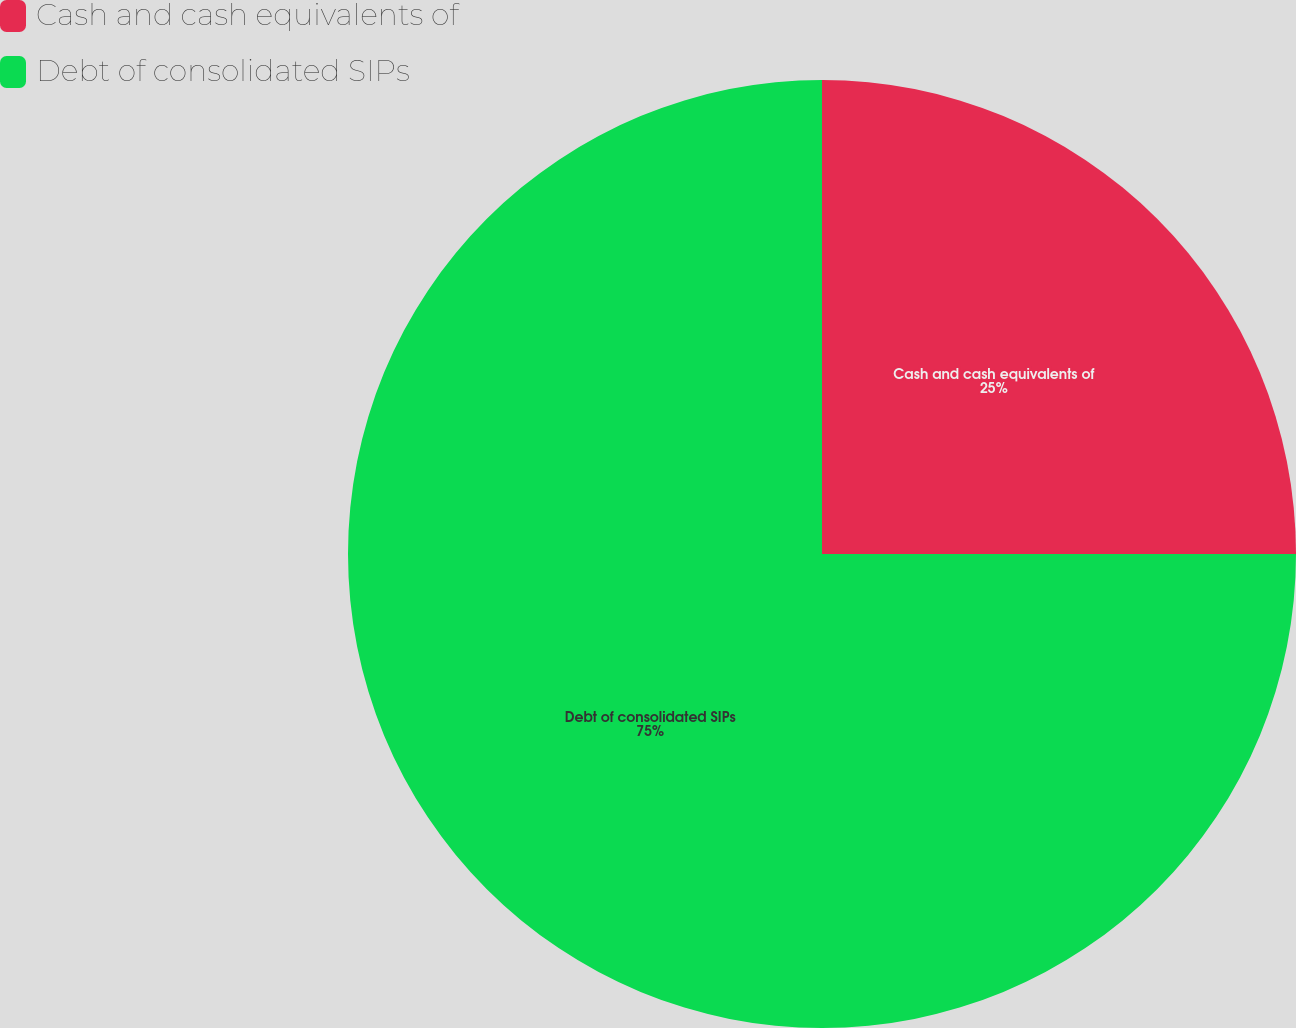Convert chart. <chart><loc_0><loc_0><loc_500><loc_500><pie_chart><fcel>Cash and cash equivalents of<fcel>Debt of consolidated SIPs<nl><fcel>25.0%<fcel>75.0%<nl></chart> 